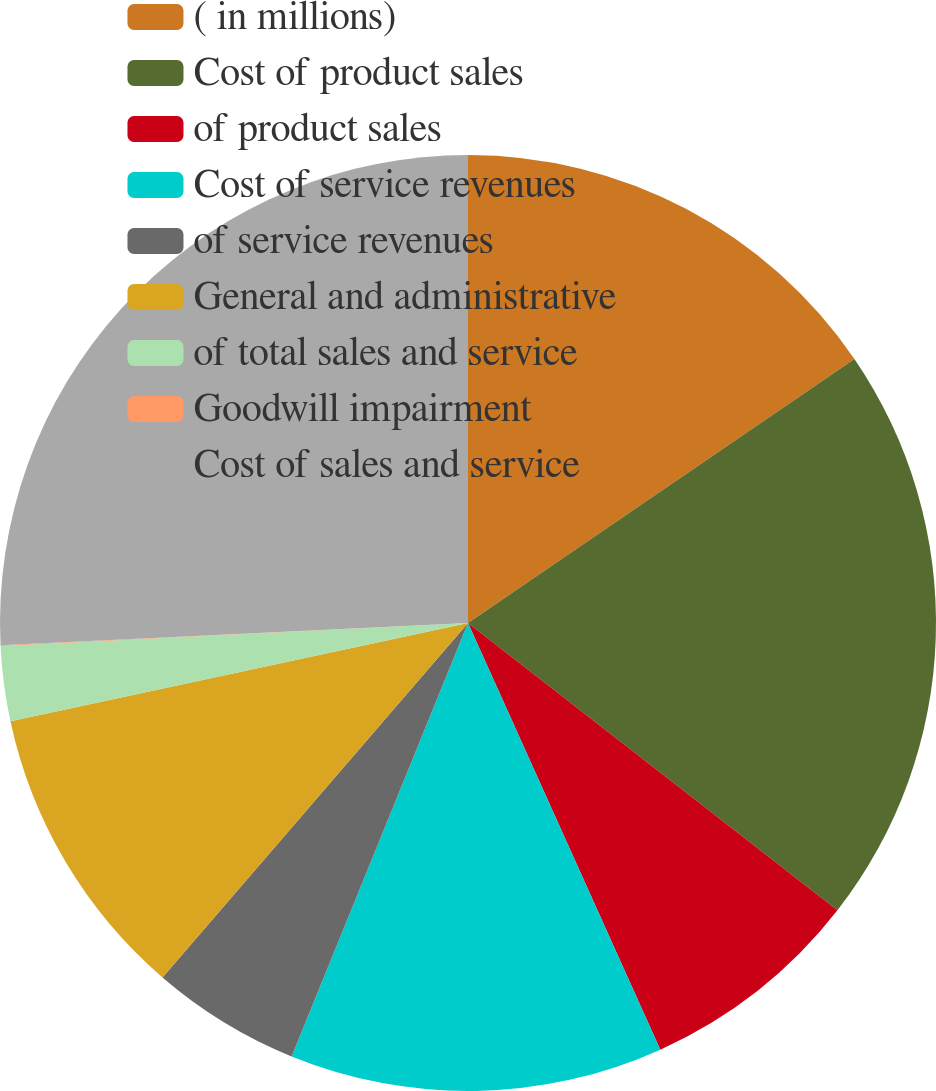<chart> <loc_0><loc_0><loc_500><loc_500><pie_chart><fcel>( in millions)<fcel>Cost of product sales<fcel>of product sales<fcel>Cost of service revenues<fcel>of service revenues<fcel>General and administrative<fcel>of total sales and service<fcel>Goodwill impairment<fcel>Cost of sales and service<nl><fcel>15.46%<fcel>20.06%<fcel>7.74%<fcel>12.89%<fcel>5.17%<fcel>10.31%<fcel>2.59%<fcel>0.02%<fcel>25.76%<nl></chart> 